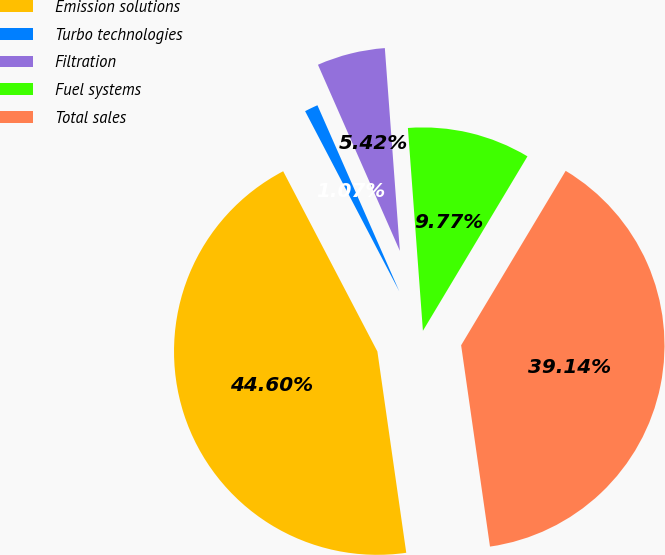Convert chart. <chart><loc_0><loc_0><loc_500><loc_500><pie_chart><fcel>Emission solutions<fcel>Turbo technologies<fcel>Filtration<fcel>Fuel systems<fcel>Total sales<nl><fcel>44.6%<fcel>1.07%<fcel>5.42%<fcel>9.77%<fcel>39.14%<nl></chart> 